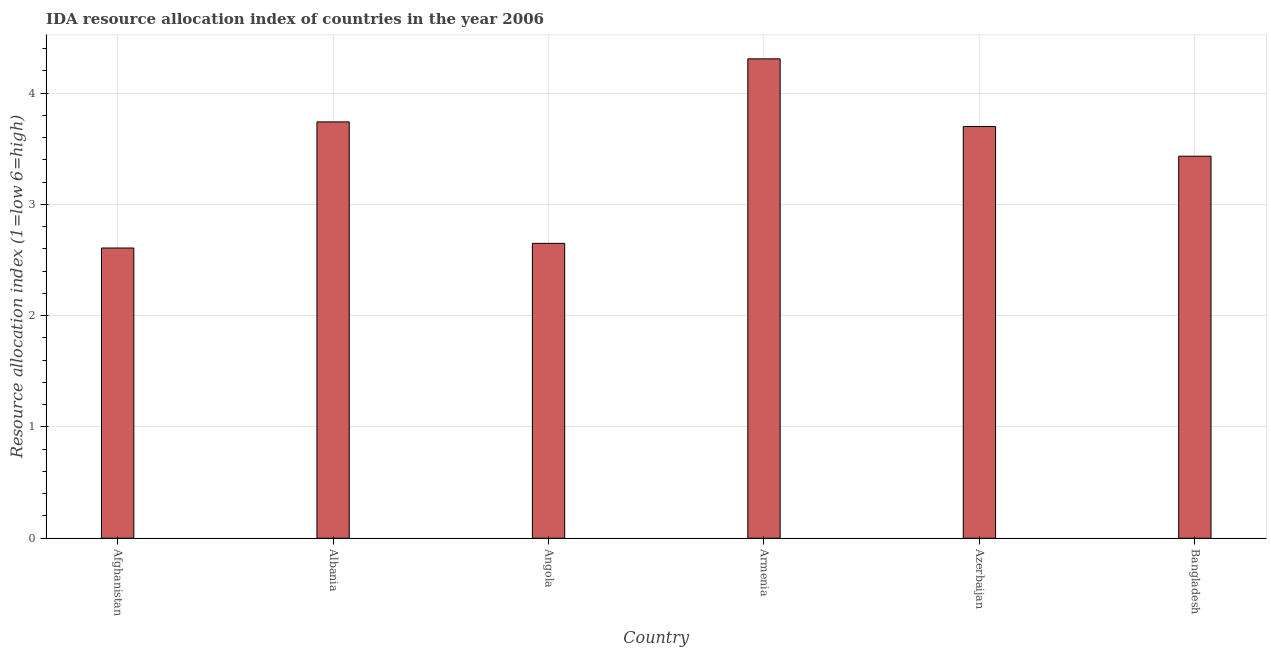Does the graph contain grids?
Your response must be concise. Yes. What is the title of the graph?
Provide a short and direct response. IDA resource allocation index of countries in the year 2006. What is the label or title of the Y-axis?
Your answer should be very brief. Resource allocation index (1=low 6=high). Across all countries, what is the maximum ida resource allocation index?
Your answer should be very brief. 4.31. Across all countries, what is the minimum ida resource allocation index?
Provide a short and direct response. 2.61. In which country was the ida resource allocation index maximum?
Give a very brief answer. Armenia. In which country was the ida resource allocation index minimum?
Keep it short and to the point. Afghanistan. What is the sum of the ida resource allocation index?
Your answer should be very brief. 20.44. What is the difference between the ida resource allocation index in Afghanistan and Angola?
Provide a succinct answer. -0.04. What is the average ida resource allocation index per country?
Keep it short and to the point. 3.41. What is the median ida resource allocation index?
Your response must be concise. 3.57. In how many countries, is the ida resource allocation index greater than 3.8 ?
Provide a short and direct response. 1. What is the ratio of the ida resource allocation index in Afghanistan to that in Albania?
Keep it short and to the point. 0.7. What is the difference between the highest and the second highest ida resource allocation index?
Offer a very short reply. 0.57. Is the sum of the ida resource allocation index in Armenia and Bangladesh greater than the maximum ida resource allocation index across all countries?
Make the answer very short. Yes. How many bars are there?
Offer a terse response. 6. Are the values on the major ticks of Y-axis written in scientific E-notation?
Provide a short and direct response. No. What is the Resource allocation index (1=low 6=high) in Afghanistan?
Keep it short and to the point. 2.61. What is the Resource allocation index (1=low 6=high) in Albania?
Your response must be concise. 3.74. What is the Resource allocation index (1=low 6=high) in Angola?
Keep it short and to the point. 2.65. What is the Resource allocation index (1=low 6=high) in Armenia?
Your answer should be compact. 4.31. What is the Resource allocation index (1=low 6=high) in Azerbaijan?
Ensure brevity in your answer.  3.7. What is the Resource allocation index (1=low 6=high) of Bangladesh?
Offer a very short reply. 3.43. What is the difference between the Resource allocation index (1=low 6=high) in Afghanistan and Albania?
Keep it short and to the point. -1.13. What is the difference between the Resource allocation index (1=low 6=high) in Afghanistan and Angola?
Ensure brevity in your answer.  -0.04. What is the difference between the Resource allocation index (1=low 6=high) in Afghanistan and Armenia?
Provide a short and direct response. -1.7. What is the difference between the Resource allocation index (1=low 6=high) in Afghanistan and Azerbaijan?
Your response must be concise. -1.09. What is the difference between the Resource allocation index (1=low 6=high) in Afghanistan and Bangladesh?
Offer a terse response. -0.82. What is the difference between the Resource allocation index (1=low 6=high) in Albania and Angola?
Provide a short and direct response. 1.09. What is the difference between the Resource allocation index (1=low 6=high) in Albania and Armenia?
Your answer should be very brief. -0.57. What is the difference between the Resource allocation index (1=low 6=high) in Albania and Azerbaijan?
Your answer should be compact. 0.04. What is the difference between the Resource allocation index (1=low 6=high) in Albania and Bangladesh?
Offer a very short reply. 0.31. What is the difference between the Resource allocation index (1=low 6=high) in Angola and Armenia?
Offer a very short reply. -1.66. What is the difference between the Resource allocation index (1=low 6=high) in Angola and Azerbaijan?
Your response must be concise. -1.05. What is the difference between the Resource allocation index (1=low 6=high) in Angola and Bangladesh?
Offer a very short reply. -0.78. What is the difference between the Resource allocation index (1=low 6=high) in Armenia and Azerbaijan?
Make the answer very short. 0.61. What is the difference between the Resource allocation index (1=low 6=high) in Armenia and Bangladesh?
Give a very brief answer. 0.88. What is the difference between the Resource allocation index (1=low 6=high) in Azerbaijan and Bangladesh?
Your answer should be compact. 0.27. What is the ratio of the Resource allocation index (1=low 6=high) in Afghanistan to that in Albania?
Offer a terse response. 0.7. What is the ratio of the Resource allocation index (1=low 6=high) in Afghanistan to that in Armenia?
Offer a terse response. 0.6. What is the ratio of the Resource allocation index (1=low 6=high) in Afghanistan to that in Azerbaijan?
Provide a short and direct response. 0.7. What is the ratio of the Resource allocation index (1=low 6=high) in Afghanistan to that in Bangladesh?
Provide a short and direct response. 0.76. What is the ratio of the Resource allocation index (1=low 6=high) in Albania to that in Angola?
Provide a succinct answer. 1.41. What is the ratio of the Resource allocation index (1=low 6=high) in Albania to that in Armenia?
Offer a terse response. 0.87. What is the ratio of the Resource allocation index (1=low 6=high) in Albania to that in Bangladesh?
Your response must be concise. 1.09. What is the ratio of the Resource allocation index (1=low 6=high) in Angola to that in Armenia?
Give a very brief answer. 0.61. What is the ratio of the Resource allocation index (1=low 6=high) in Angola to that in Azerbaijan?
Give a very brief answer. 0.72. What is the ratio of the Resource allocation index (1=low 6=high) in Angola to that in Bangladesh?
Give a very brief answer. 0.77. What is the ratio of the Resource allocation index (1=low 6=high) in Armenia to that in Azerbaijan?
Make the answer very short. 1.16. What is the ratio of the Resource allocation index (1=low 6=high) in Armenia to that in Bangladesh?
Make the answer very short. 1.25. What is the ratio of the Resource allocation index (1=low 6=high) in Azerbaijan to that in Bangladesh?
Offer a very short reply. 1.08. 